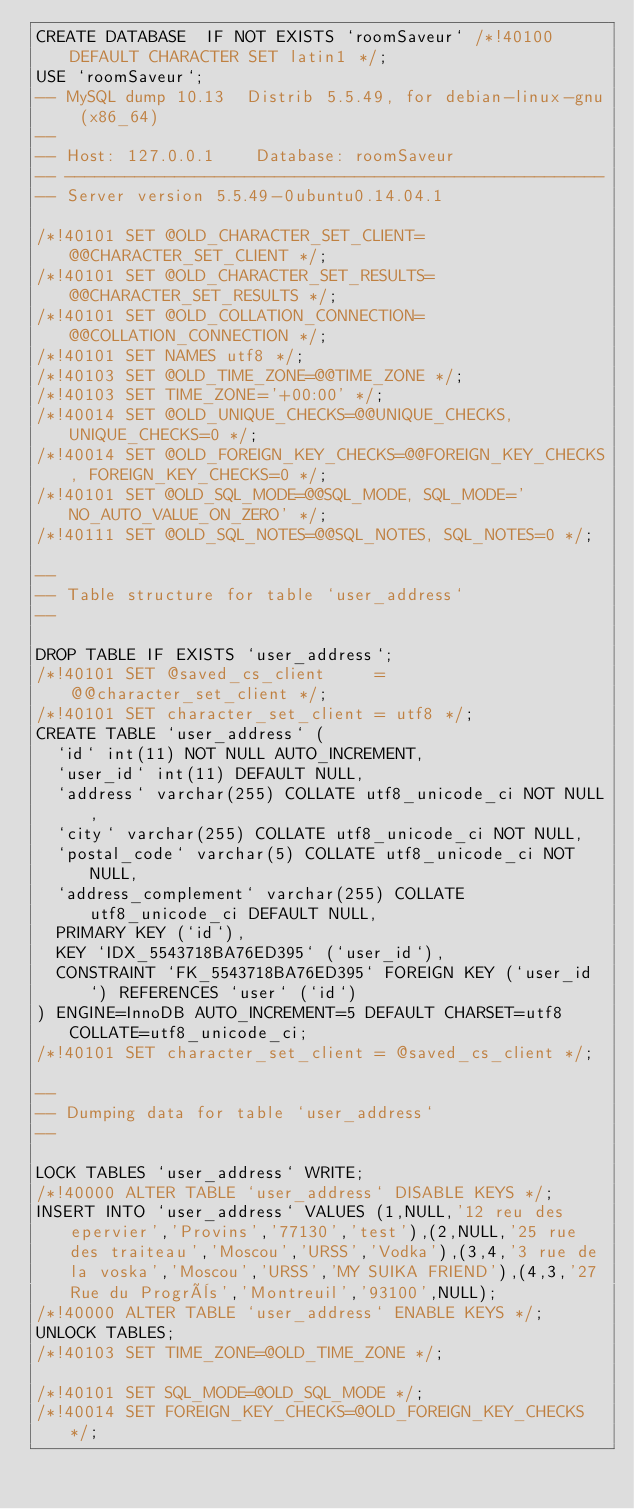<code> <loc_0><loc_0><loc_500><loc_500><_SQL_>CREATE DATABASE  IF NOT EXISTS `roomSaveur` /*!40100 DEFAULT CHARACTER SET latin1 */;
USE `roomSaveur`;
-- MySQL dump 10.13  Distrib 5.5.49, for debian-linux-gnu (x86_64)
--
-- Host: 127.0.0.1    Database: roomSaveur
-- ------------------------------------------------------
-- Server version	5.5.49-0ubuntu0.14.04.1

/*!40101 SET @OLD_CHARACTER_SET_CLIENT=@@CHARACTER_SET_CLIENT */;
/*!40101 SET @OLD_CHARACTER_SET_RESULTS=@@CHARACTER_SET_RESULTS */;
/*!40101 SET @OLD_COLLATION_CONNECTION=@@COLLATION_CONNECTION */;
/*!40101 SET NAMES utf8 */;
/*!40103 SET @OLD_TIME_ZONE=@@TIME_ZONE */;
/*!40103 SET TIME_ZONE='+00:00' */;
/*!40014 SET @OLD_UNIQUE_CHECKS=@@UNIQUE_CHECKS, UNIQUE_CHECKS=0 */;
/*!40014 SET @OLD_FOREIGN_KEY_CHECKS=@@FOREIGN_KEY_CHECKS, FOREIGN_KEY_CHECKS=0 */;
/*!40101 SET @OLD_SQL_MODE=@@SQL_MODE, SQL_MODE='NO_AUTO_VALUE_ON_ZERO' */;
/*!40111 SET @OLD_SQL_NOTES=@@SQL_NOTES, SQL_NOTES=0 */;

--
-- Table structure for table `user_address`
--

DROP TABLE IF EXISTS `user_address`;
/*!40101 SET @saved_cs_client     = @@character_set_client */;
/*!40101 SET character_set_client = utf8 */;
CREATE TABLE `user_address` (
  `id` int(11) NOT NULL AUTO_INCREMENT,
  `user_id` int(11) DEFAULT NULL,
  `address` varchar(255) COLLATE utf8_unicode_ci NOT NULL,
  `city` varchar(255) COLLATE utf8_unicode_ci NOT NULL,
  `postal_code` varchar(5) COLLATE utf8_unicode_ci NOT NULL,
  `address_complement` varchar(255) COLLATE utf8_unicode_ci DEFAULT NULL,
  PRIMARY KEY (`id`),
  KEY `IDX_5543718BA76ED395` (`user_id`),
  CONSTRAINT `FK_5543718BA76ED395` FOREIGN KEY (`user_id`) REFERENCES `user` (`id`)
) ENGINE=InnoDB AUTO_INCREMENT=5 DEFAULT CHARSET=utf8 COLLATE=utf8_unicode_ci;
/*!40101 SET character_set_client = @saved_cs_client */;

--
-- Dumping data for table `user_address`
--

LOCK TABLES `user_address` WRITE;
/*!40000 ALTER TABLE `user_address` DISABLE KEYS */;
INSERT INTO `user_address` VALUES (1,NULL,'12 reu des epervier','Provins','77130','test'),(2,NULL,'25 rue des traiteau','Moscou','URSS','Vodka'),(3,4,'3 rue de la voska','Moscou','URSS','MY SUIKA FRIEND'),(4,3,'27 Rue du Progrès','Montreuil','93100',NULL);
/*!40000 ALTER TABLE `user_address` ENABLE KEYS */;
UNLOCK TABLES;
/*!40103 SET TIME_ZONE=@OLD_TIME_ZONE */;

/*!40101 SET SQL_MODE=@OLD_SQL_MODE */;
/*!40014 SET FOREIGN_KEY_CHECKS=@OLD_FOREIGN_KEY_CHECKS */;</code> 